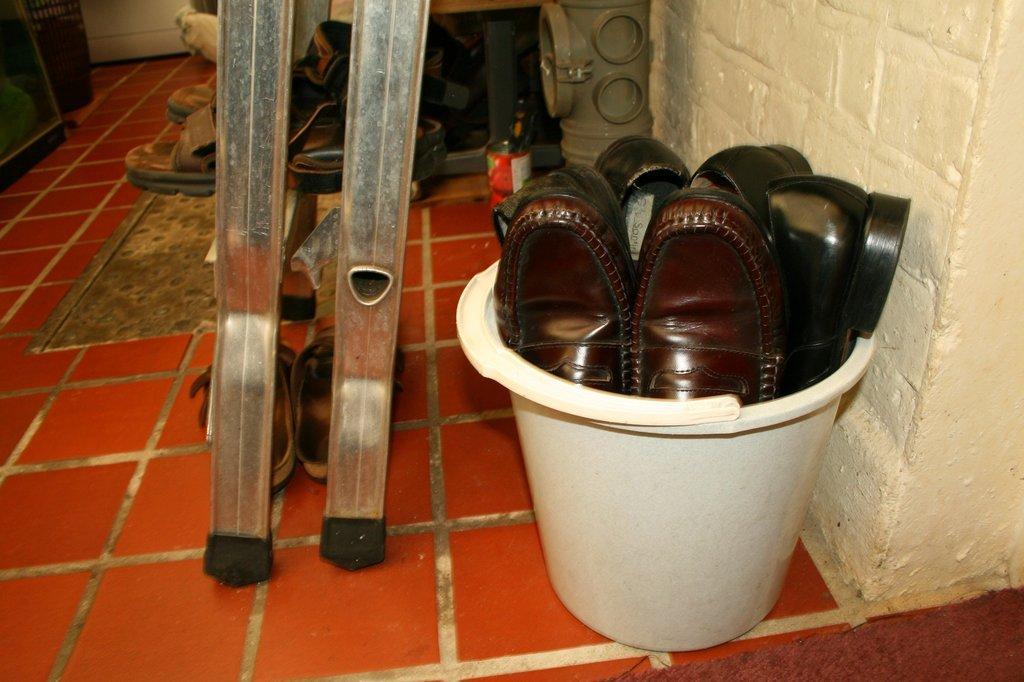Please provide a concise description of this image. In this picture I can see the shoes in a bucket, in the middle there are sandals on the metal rods. 